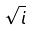<formula> <loc_0><loc_0><loc_500><loc_500>\sqrt { i }</formula> 